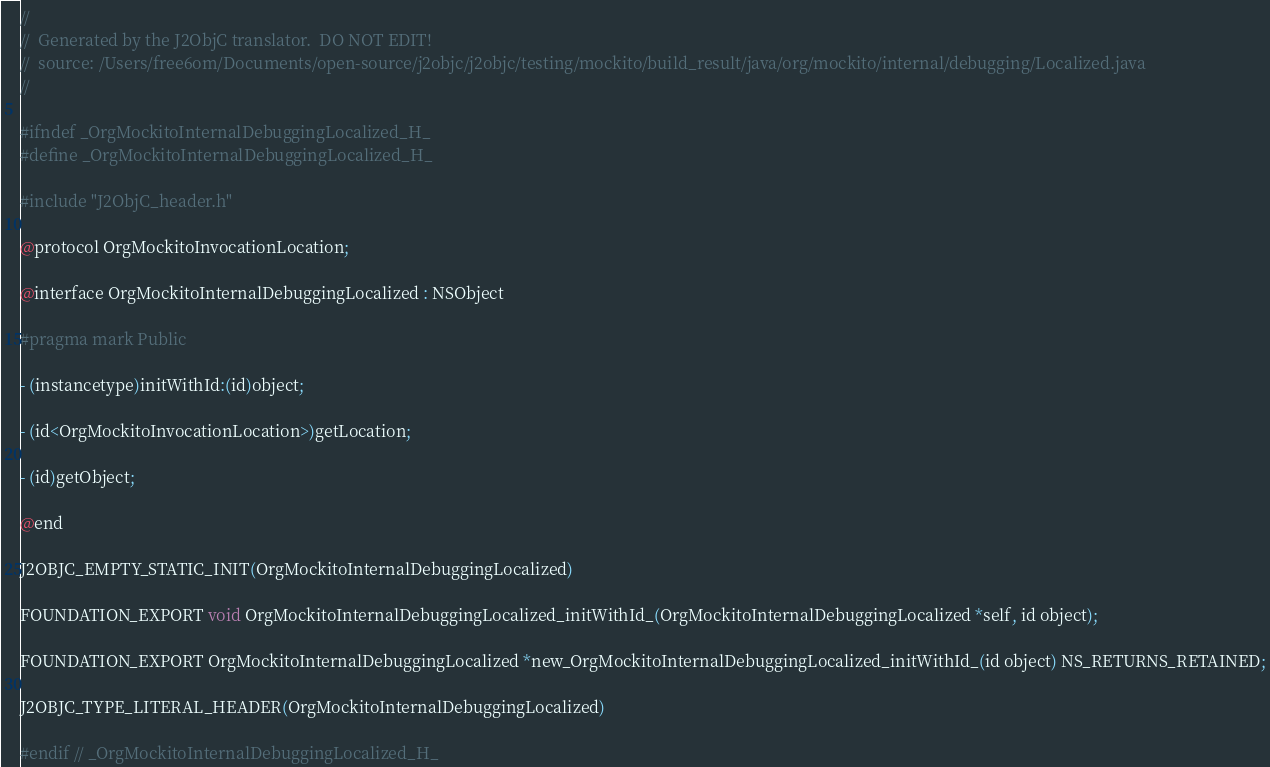<code> <loc_0><loc_0><loc_500><loc_500><_C_>//
//  Generated by the J2ObjC translator.  DO NOT EDIT!
//  source: /Users/free6om/Documents/open-source/j2objc/j2objc/testing/mockito/build_result/java/org/mockito/internal/debugging/Localized.java
//

#ifndef _OrgMockitoInternalDebuggingLocalized_H_
#define _OrgMockitoInternalDebuggingLocalized_H_

#include "J2ObjC_header.h"

@protocol OrgMockitoInvocationLocation;

@interface OrgMockitoInternalDebuggingLocalized : NSObject

#pragma mark Public

- (instancetype)initWithId:(id)object;

- (id<OrgMockitoInvocationLocation>)getLocation;

- (id)getObject;

@end

J2OBJC_EMPTY_STATIC_INIT(OrgMockitoInternalDebuggingLocalized)

FOUNDATION_EXPORT void OrgMockitoInternalDebuggingLocalized_initWithId_(OrgMockitoInternalDebuggingLocalized *self, id object);

FOUNDATION_EXPORT OrgMockitoInternalDebuggingLocalized *new_OrgMockitoInternalDebuggingLocalized_initWithId_(id object) NS_RETURNS_RETAINED;

J2OBJC_TYPE_LITERAL_HEADER(OrgMockitoInternalDebuggingLocalized)

#endif // _OrgMockitoInternalDebuggingLocalized_H_
</code> 